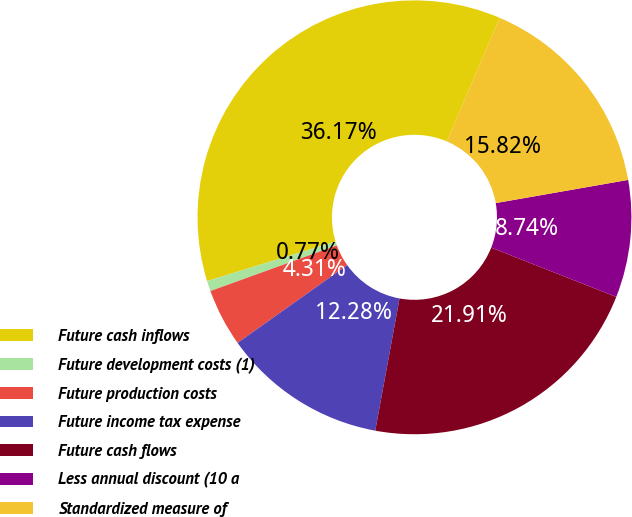Convert chart. <chart><loc_0><loc_0><loc_500><loc_500><pie_chart><fcel>Future cash inflows<fcel>Future development costs (1)<fcel>Future production costs<fcel>Future income tax expense<fcel>Future cash flows<fcel>Less annual discount (10 a<fcel>Standardized measure of<nl><fcel>36.17%<fcel>0.77%<fcel>4.31%<fcel>12.28%<fcel>21.91%<fcel>8.74%<fcel>15.82%<nl></chart> 